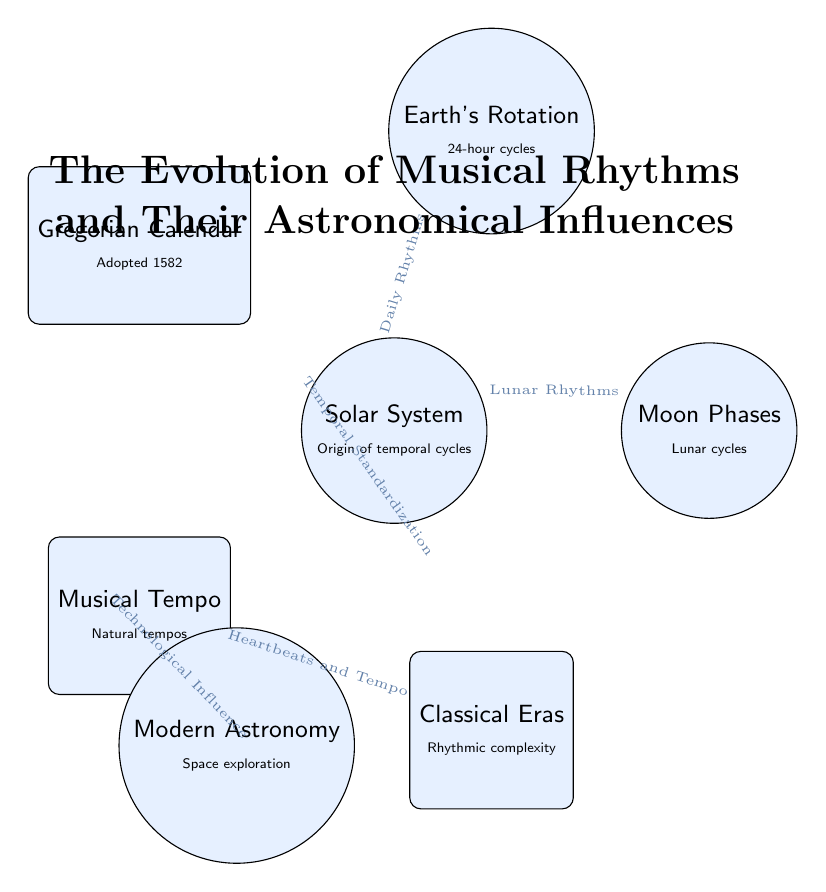What are the celestial influences mentioned in the diagram? The diagram lists "Solar System," "Moon Phases," "Earth's Rotation," and "Modern Astronomy" as the celestial influences. These terms are represented in rounded circles and are prominently displayed, indicating their roles within the framework of musical rhythms and their astronomical connections.
Answer: Solar System, Moon Phases, Earth's Rotation, Modern Astronomy What connects the Solar System to Moon Phases? The edge labeled "Lunar Rhythms" connects the Solar System to Moon Phases. This arrow indicates the flow of influence or relationship between these two nodes, where the lunar rhythms derived from the moon impact musical elements.
Answer: Lunar Rhythms How many nodes are there in total? By counting all the circles and rectangles in the diagram, we can see there are a total of 7 nodes: 4 celestial and 3 musical. This is verified by recognizing the distinct shapes and labels representing each node's concept.
Answer: 7 Which musical node is linked to the classical eras? The "Gregorian Calendar" is connected to the "Classical Eras" through the arrow indicating "Temporal Standardization." This demonstrates a historical progression in musical practice informed by celestial phenomena contributing to the development of timekeeping in music.
Answer: Gregorian Calendar What does modern astronomy influence in the diagram? Modern Astronomy influences the "Musical Tempo," as indicated by the arrow labeled "Technological Influence." This suggests how advancements in astronomy have impacted the understanding and application of tempo in music over time.
Answer: Musical Tempo What is the nature of the connection between the "Earth's Rotation" and the "Moon Phases"? The diagram shows that both the Earth’s Rotation and Moon Phases are directly connected to the Solar System, with "Daily Rhythms" flowing from the Solar System to "Earth's Rotation" and "Lunar Rhythms" from the Solar System to "Moon Phases.” This indicates that both aspects are derived from the same celestial origin.
Answer: Both are connected to the Solar System What type of nodes are connected by the “Heartbeats and Tempo”? The "Heartbeats and Tempo" connection exists between the musical node "Musical Tempo" and "Classical Eras." This indicates a relationship where natural rhythms, like heartbeats, influence the understanding of tempo in the context of more complex musical structures during classical music periods.
Answer: Musical nodes How is the influence of lunar rhythms established in the diagram? The influence of lunar rhythms is established by drawing a directed edge from "Solar System" to "Moon Phases," signifying that the broader celestial system sets the foundational rhythms that manifest in lunar cycles.
Answer: By directed edge from Solar System to Moon Phases 